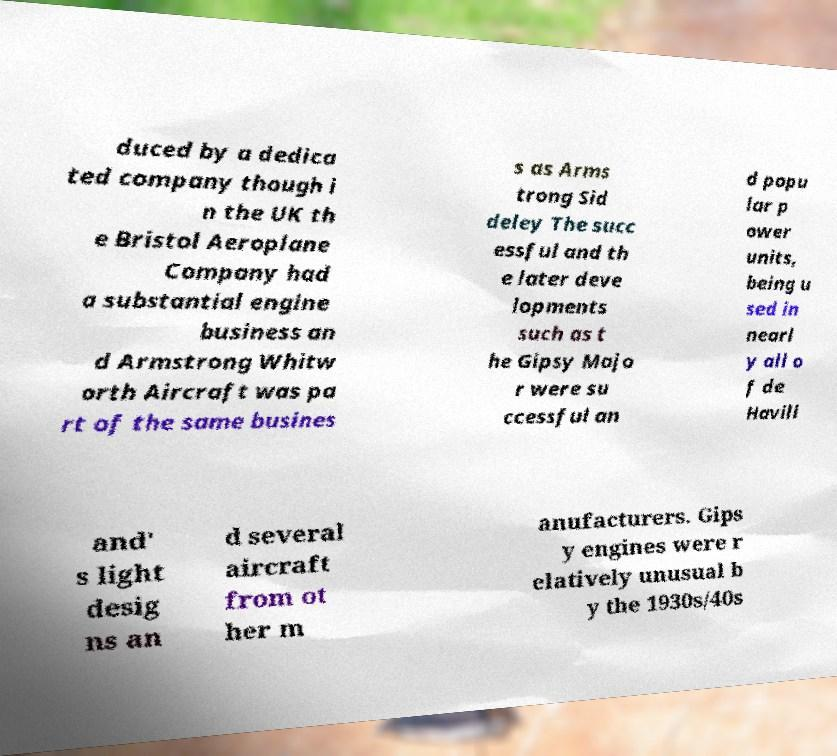Could you extract and type out the text from this image? duced by a dedica ted company though i n the UK th e Bristol Aeroplane Company had a substantial engine business an d Armstrong Whitw orth Aircraft was pa rt of the same busines s as Arms trong Sid deley The succ essful and th e later deve lopments such as t he Gipsy Majo r were su ccessful an d popu lar p ower units, being u sed in nearl y all o f de Havill and' s light desig ns an d several aircraft from ot her m anufacturers. Gips y engines were r elatively unusual b y the 1930s/40s 